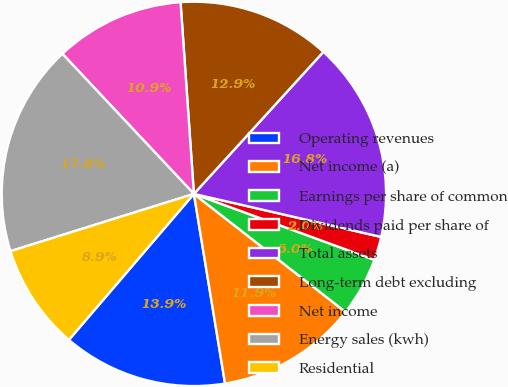<chart> <loc_0><loc_0><loc_500><loc_500><pie_chart><fcel>Operating revenues<fcel>Net income (a)<fcel>Earnings per share of common<fcel>Dividends paid per share of<fcel>Total assets<fcel>Long-term debt excluding<fcel>Net income<fcel>Energy sales (kwh)<fcel>Residential<nl><fcel>13.86%<fcel>11.88%<fcel>4.95%<fcel>1.98%<fcel>16.83%<fcel>12.87%<fcel>10.89%<fcel>17.82%<fcel>8.91%<nl></chart> 